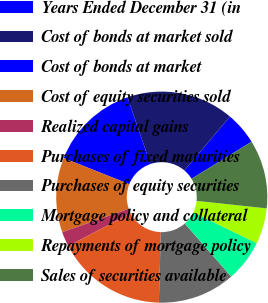Convert chart to OTSL. <chart><loc_0><loc_0><loc_500><loc_500><pie_chart><fcel>Years Ended December 31 (in<fcel>Cost of bonds at market sold<fcel>Cost of bonds at market<fcel>Cost of equity securities sold<fcel>Realized capital gains<fcel>Purchases of fixed maturities<fcel>Purchases of equity securities<fcel>Mortgage policy and collateral<fcel>Repayments of mortgage policy<fcel>Sales of securities available<nl><fcel>5.02%<fcel>16.44%<fcel>13.7%<fcel>11.42%<fcel>2.28%<fcel>16.89%<fcel>11.87%<fcel>6.39%<fcel>5.48%<fcel>10.5%<nl></chart> 